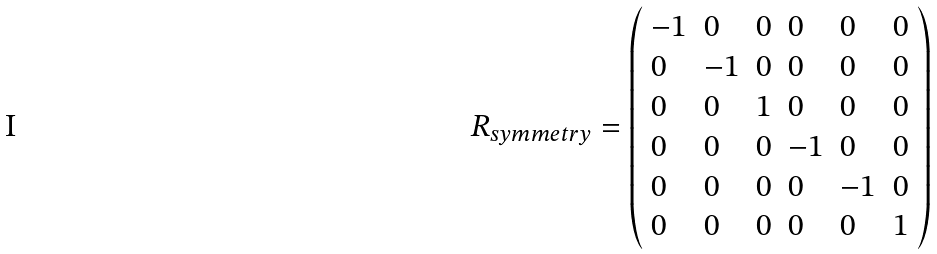<formula> <loc_0><loc_0><loc_500><loc_500>R _ { s y m m e t r y } = \left ( \begin{array} { l l l l l l } { - 1 } & { 0 } & { 0 } & { 0 } & { 0 } & { 0 } \\ { 0 } & { - 1 } & { 0 } & { 0 } & { 0 } & { 0 } \\ { 0 } & { 0 } & { 1 } & { 0 } & { 0 } & { 0 } \\ { 0 } & { 0 } & { 0 } & { - 1 } & { 0 } & { 0 } \\ { 0 } & { 0 } & { 0 } & { 0 } & { - 1 } & { 0 } \\ { 0 } & { 0 } & { 0 } & { 0 } & { 0 } & { 1 } \end{array} \right )</formula> 